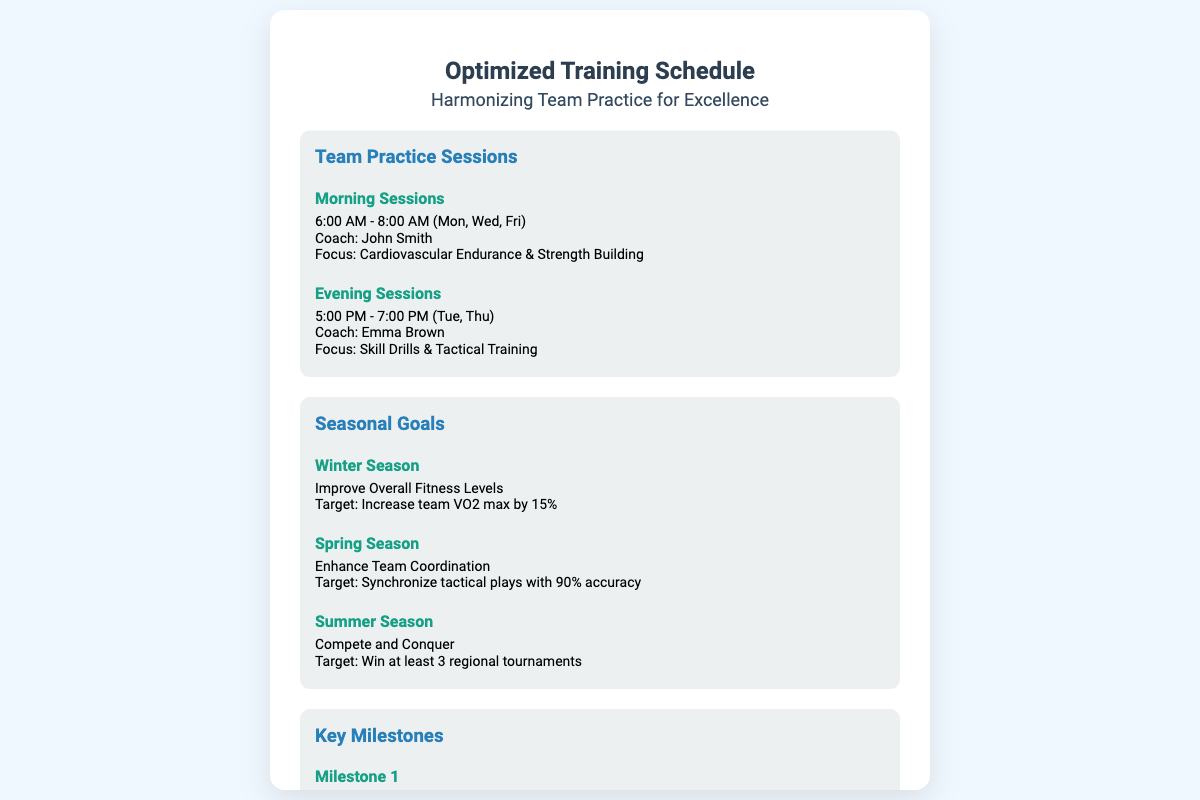what time is the morning practice session? The morning practice session runs from 6:00 AM to 8:00 AM.
Answer: 6:00 AM - 8:00 AM who is the coach for the evening sessions? The coach for the evening sessions is Emma Brown.
Answer: Emma Brown what is the target VO2 max increase for the winter season? The target for the winter season is a 15% increase in team VO2 max.
Answer: 15% when is the mid-season performance review scheduled? The mid-season performance review is on April 1st.
Answer: April 1st what is the objective of the end-of-season tournament? The objective is to showcase team progress and achieve set targets.
Answer: Showcase team progress how many regional tournaments does the team aim to win in the summer season? The team aims to win at least 3 regional tournaments.
Answer: 3 which area of focus is highlighted for morning sessions? The focus for morning sessions is on cardiovascular endurance and strength building.
Answer: Cardiovascular Endurance & Strength Building how often do the morning sessions occur? The morning sessions occur three times a week on Monday, Wednesday, and Friday.
Answer: Mon, Wed, Fri what season's goal is to enhance team coordination? The goal to enhance team coordination is set for the spring season.
Answer: Spring Season 